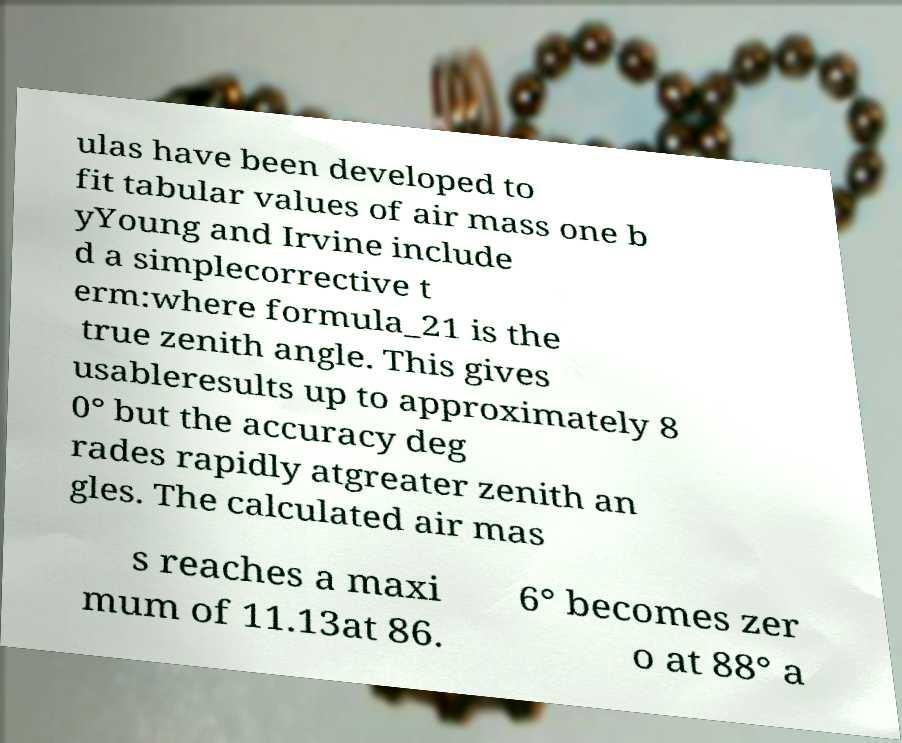What messages or text are displayed in this image? I need them in a readable, typed format. ulas have been developed to fit tabular values of air mass one b yYoung and Irvine include d a simplecorrective t erm:where formula_21 is the true zenith angle. This gives usableresults up to approximately 8 0° but the accuracy deg rades rapidly atgreater zenith an gles. The calculated air mas s reaches a maxi mum of 11.13at 86. 6° becomes zer o at 88° a 